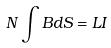<formula> <loc_0><loc_0><loc_500><loc_500>N \int B d S = L I</formula> 